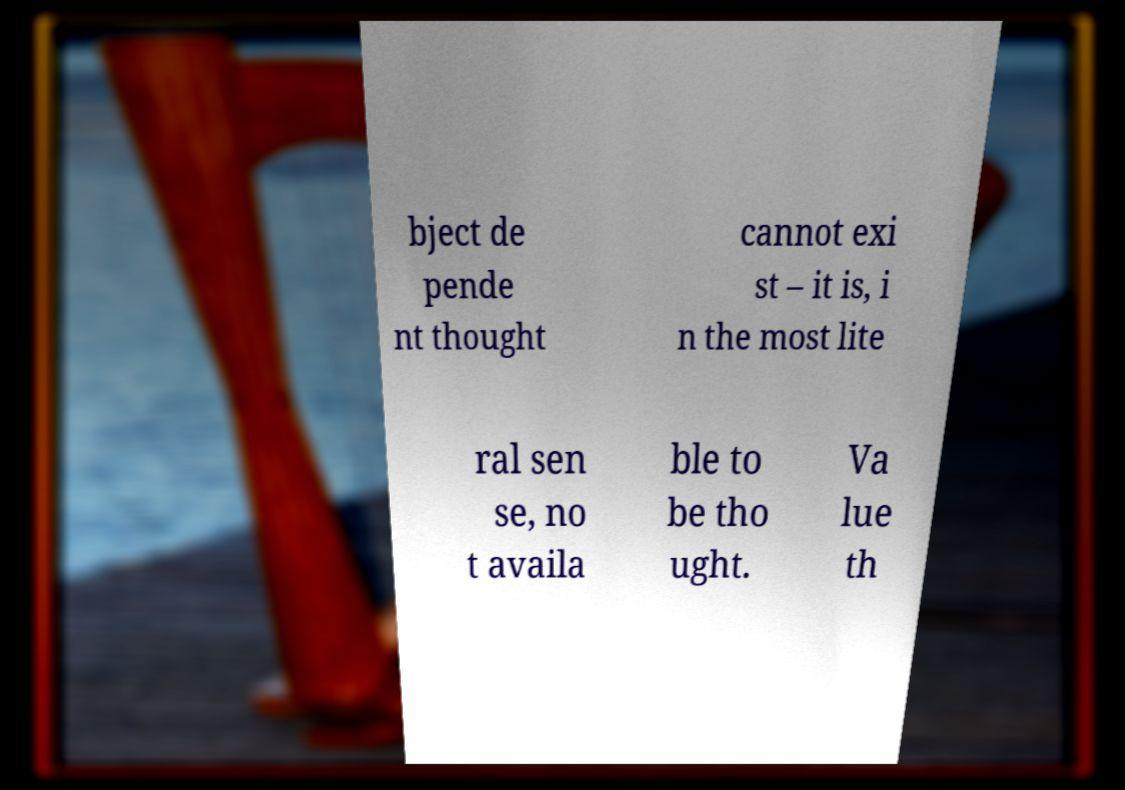Can you accurately transcribe the text from the provided image for me? bject de pende nt thought cannot exi st – it is, i n the most lite ral sen se, no t availa ble to be tho ught. Va lue th 